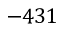<formula> <loc_0><loc_0><loc_500><loc_500>- 4 3 1</formula> 